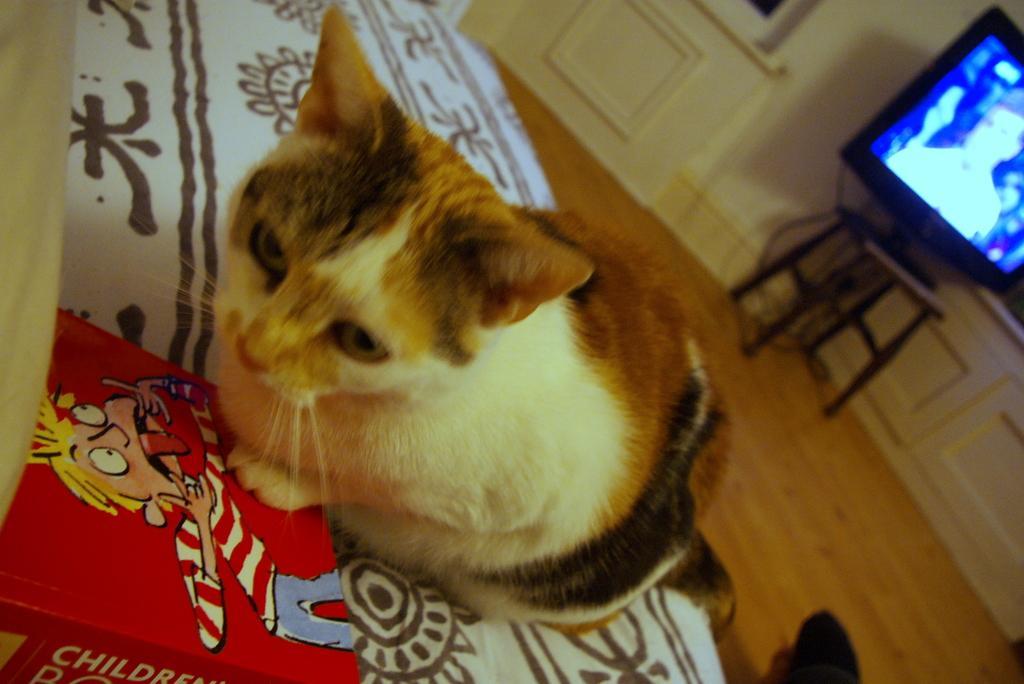In one or two sentences, can you explain what this image depicts? In this image, we can see a cat on the bed. There is a book in the bottom left of the image. There is a TV on the stool which is on the right side of the image. 